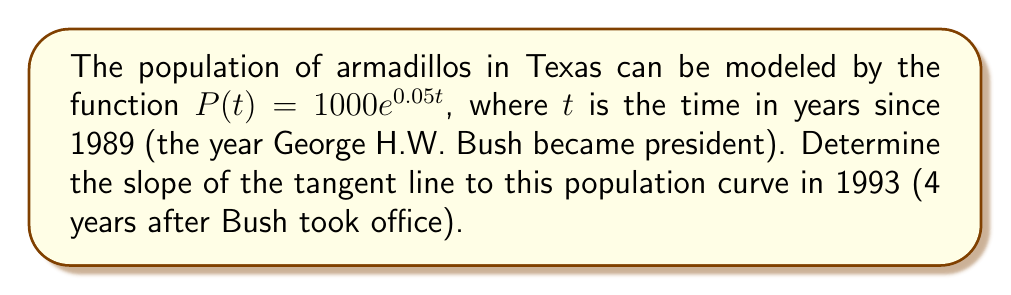Provide a solution to this math problem. Let's approach this step-by-step:

1) The slope of the tangent line at any point is equal to the derivative of the function at that point.

2) First, we need to find the derivative of $P(t)$:
   $$\frac{d}{dt}P(t) = \frac{d}{dt}(1000e^{0.05t})$$
   $$P'(t) = 1000 \cdot 0.05e^{0.05t}$$
   $$P'(t) = 50e^{0.05t}$$

3) Now, we need to evaluate this derivative at $t = 4$ (since 1993 is 4 years after 1989):
   $$P'(4) = 50e^{0.05(4)}$$
   $$P'(4) = 50e^{0.2}$$

4) Using a calculator or e^0.2 ≈ 1.2214:
   $$P'(4) = 50 \cdot 1.2214 \approx 61.07$$

5) Therefore, the slope of the tangent line in 1993 is approximately 61.07 armadillos per year.
Answer: $61.07$ armadillos/year 